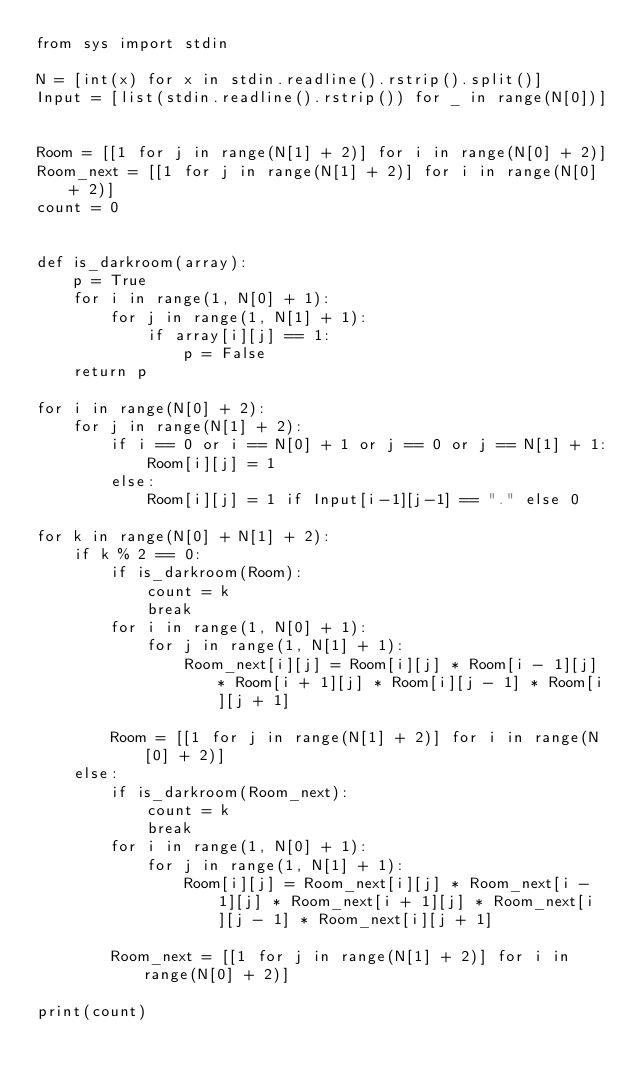<code> <loc_0><loc_0><loc_500><loc_500><_Python_>from sys import stdin

N = [int(x) for x in stdin.readline().rstrip().split()]
Input = [list(stdin.readline().rstrip()) for _ in range(N[0])]


Room = [[1 for j in range(N[1] + 2)] for i in range(N[0] + 2)]
Room_next = [[1 for j in range(N[1] + 2)] for i in range(N[0] + 2)]
count = 0


def is_darkroom(array):
    p = True
    for i in range(1, N[0] + 1):
        for j in range(1, N[1] + 1):
            if array[i][j] == 1:
                p = False
    return p

for i in range(N[0] + 2):
    for j in range(N[1] + 2):
        if i == 0 or i == N[0] + 1 or j == 0 or j == N[1] + 1:
            Room[i][j] = 1
        else:
            Room[i][j] = 1 if Input[i-1][j-1] == "." else 0

for k in range(N[0] + N[1] + 2):
    if k % 2 == 0:
        if is_darkroom(Room):
            count = k
            break
        for i in range(1, N[0] + 1):
            for j in range(1, N[1] + 1):
                Room_next[i][j] = Room[i][j] * Room[i - 1][j] * Room[i + 1][j] * Room[i][j - 1] * Room[i][j + 1]

        Room = [[1 for j in range(N[1] + 2)] for i in range(N[0] + 2)]
    else:
        if is_darkroom(Room_next):
            count = k
            break
        for i in range(1, N[0] + 1):
            for j in range(1, N[1] + 1):
                Room[i][j] = Room_next[i][j] * Room_next[i - 1][j] * Room_next[i + 1][j] * Room_next[i][j - 1] * Room_next[i][j + 1]

        Room_next = [[1 for j in range(N[1] + 2)] for i in range(N[0] + 2)]       

print(count)</code> 